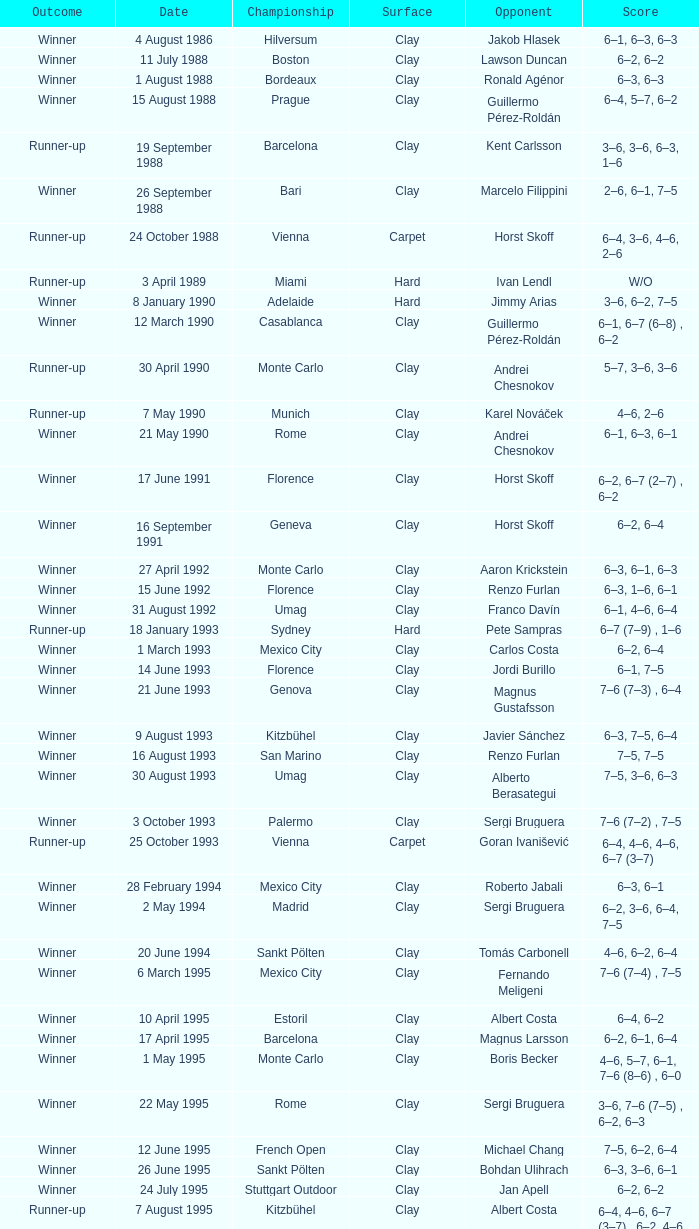In the championship, what is the score when rome faces richard krajicek as the opponent? 6–2, 6–4, 3–6, 6–3. 